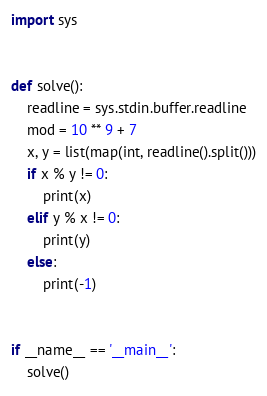<code> <loc_0><loc_0><loc_500><loc_500><_Python_>import sys


def solve():
    readline = sys.stdin.buffer.readline
    mod = 10 ** 9 + 7
    x, y = list(map(int, readline().split()))
    if x % y != 0:
        print(x)
    elif y % x != 0:
        print(y)
    else:
        print(-1)


if __name__ == '__main__':
    solve()
</code> 